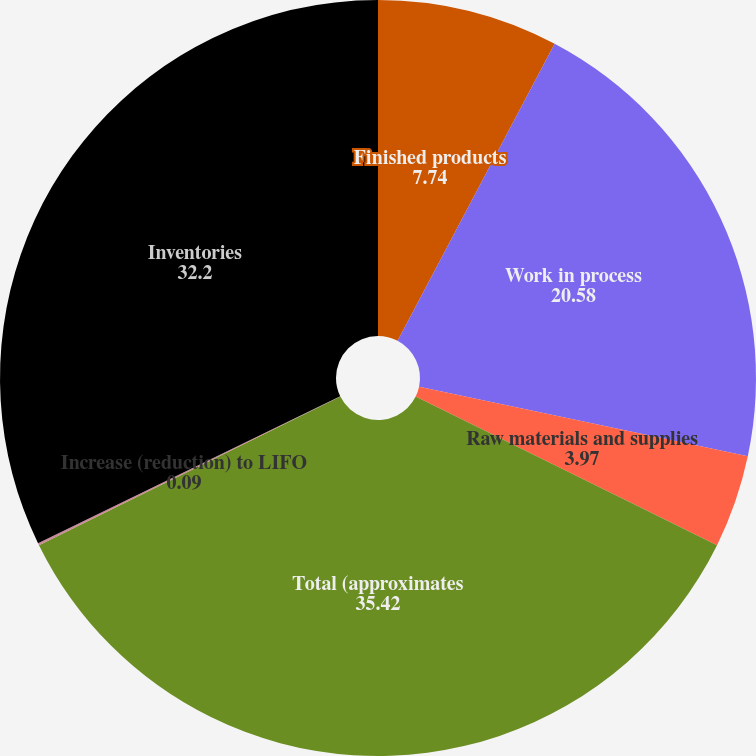Convert chart to OTSL. <chart><loc_0><loc_0><loc_500><loc_500><pie_chart><fcel>Finished products<fcel>Work in process<fcel>Raw materials and supplies<fcel>Total (approximates<fcel>Increase (reduction) to LIFO<fcel>Inventories<nl><fcel>7.74%<fcel>20.58%<fcel>3.97%<fcel>35.42%<fcel>0.09%<fcel>32.2%<nl></chart> 